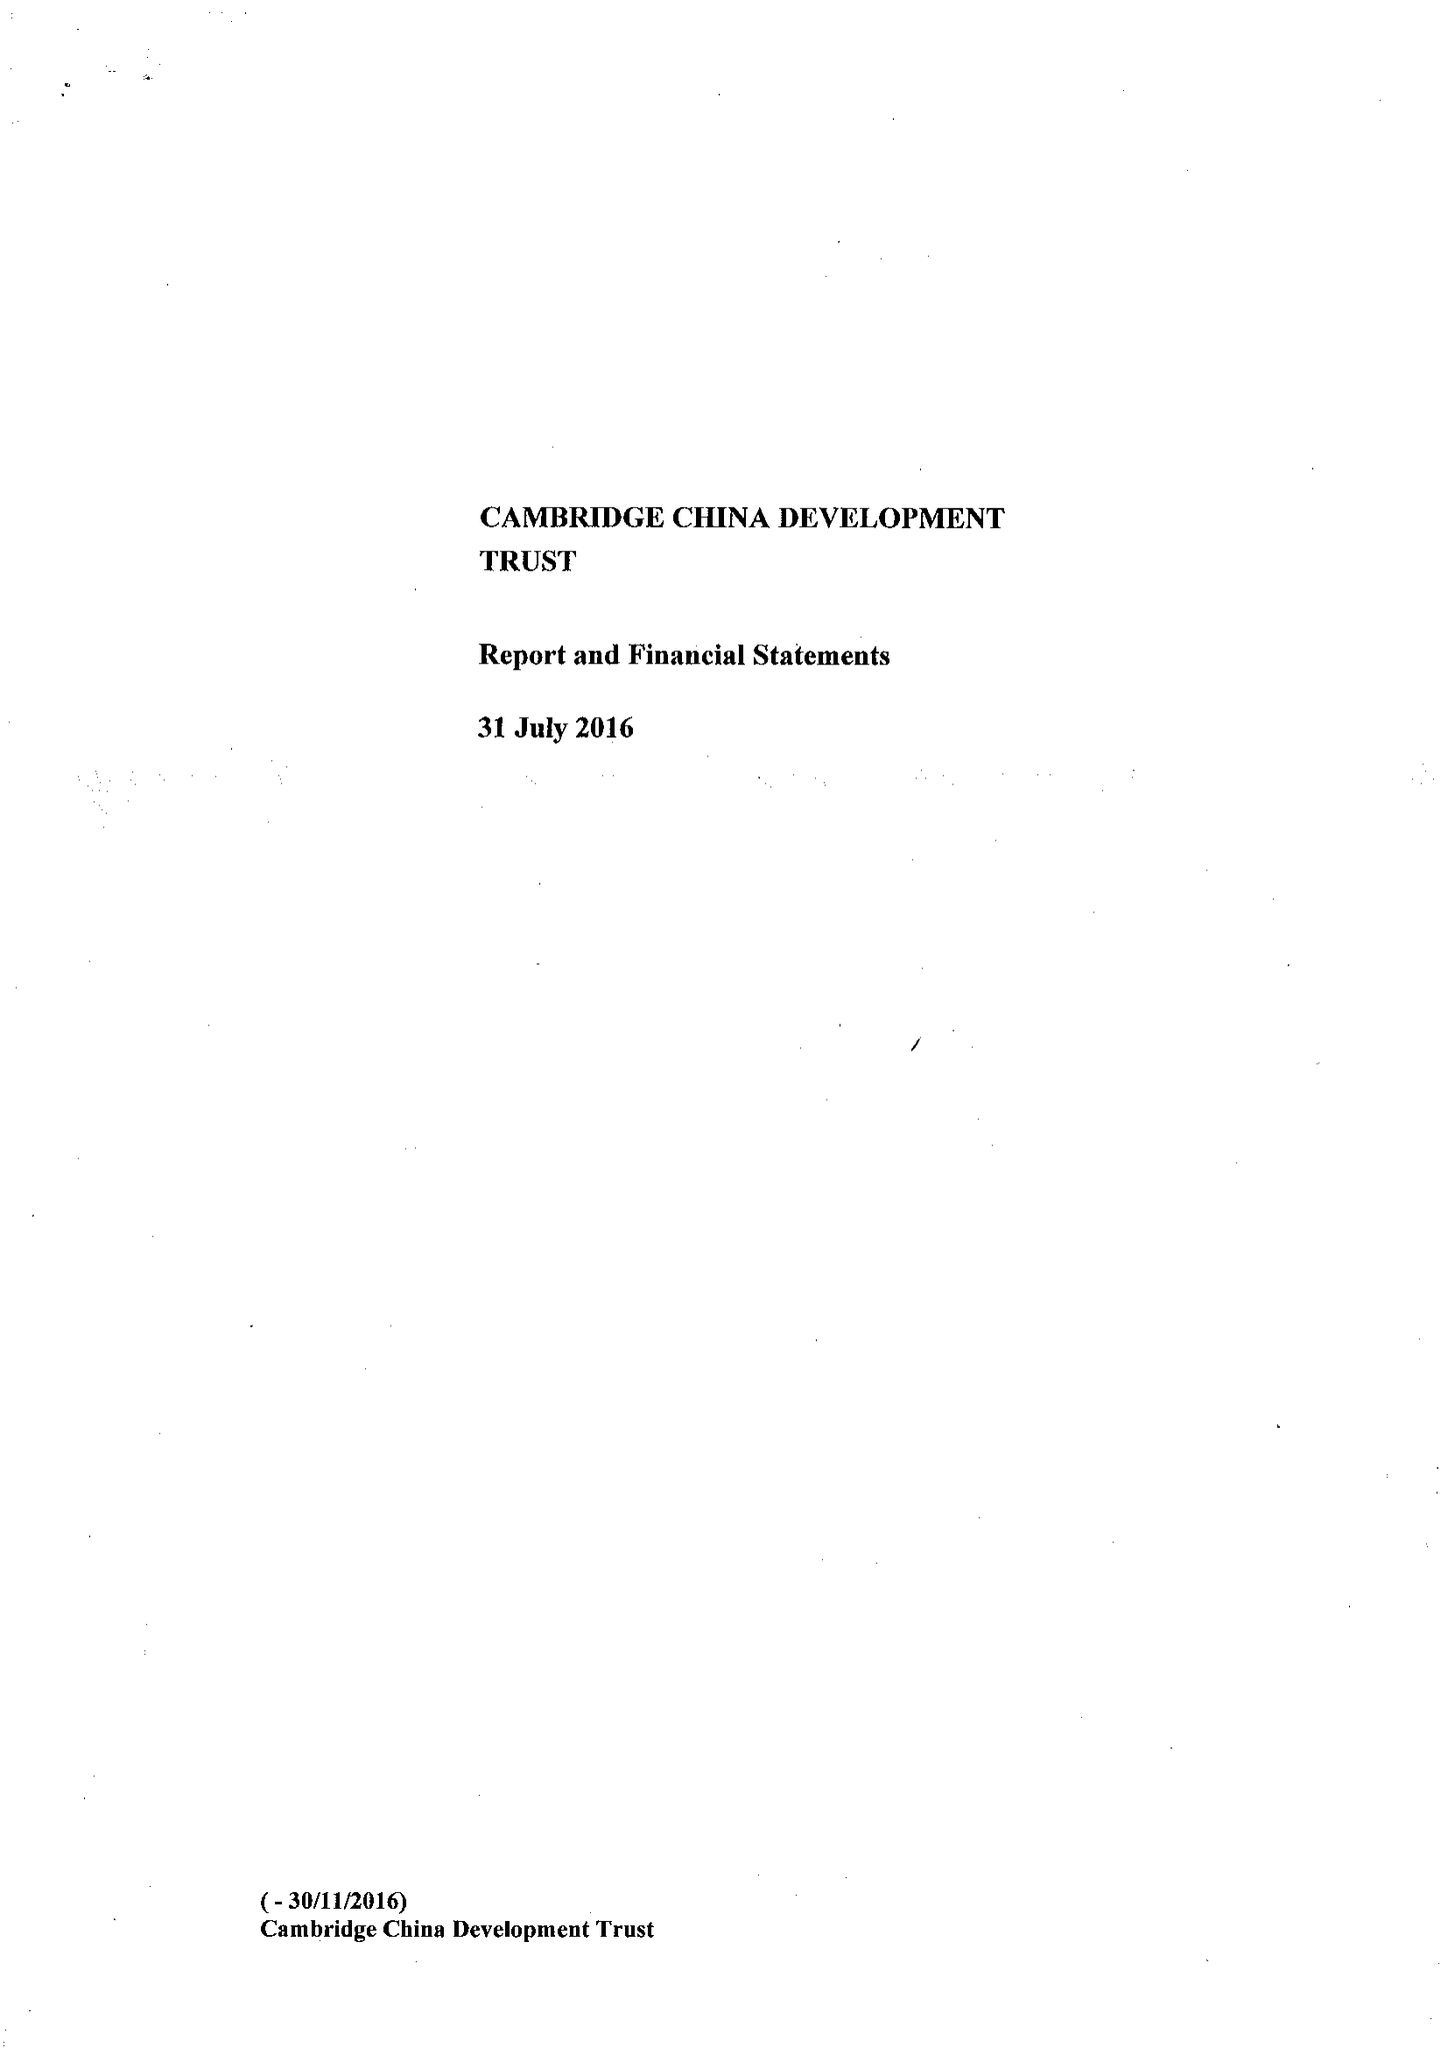What is the value for the report_date?
Answer the question using a single word or phrase. 2016-07-31 